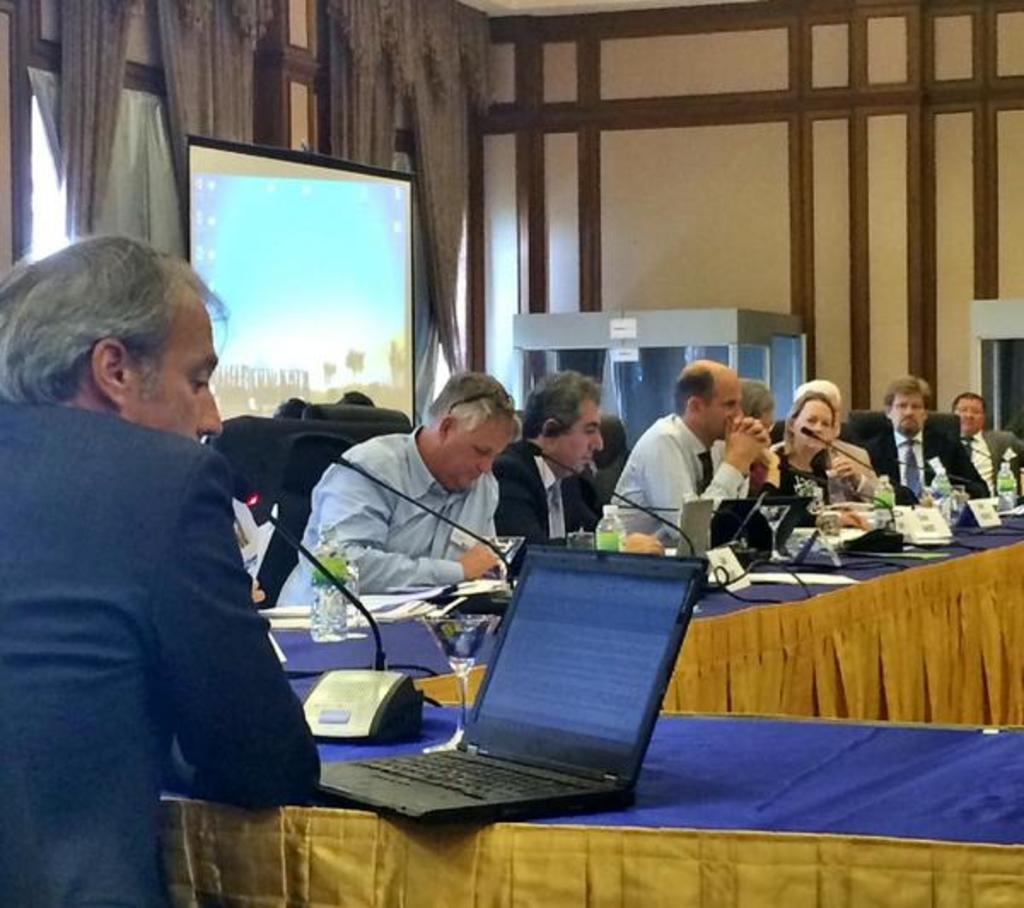How many people are in the image? There are many people in the image. What are the people doing in the image? The people are sitting on chairs and operating laptops. What are the people using to communicate with others? The people are using microphones. What is in the background of the image? There is a big TV screen in the background. What type of marble is present on the table in the image? There is no marble present on the table in the image. What kind of locket can be seen around the neck of one of the people in the image? There are no lockets visible on any of the people in the image. 